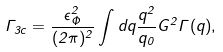<formula> <loc_0><loc_0><loc_500><loc_500>\Gamma _ { 3 c } = \frac { \epsilon _ { \Phi } ^ { 2 } } { ( 2 \pi ) ^ { 2 } } \int d q \frac { q ^ { 2 } } { q _ { 0 } } G ^ { 2 } \Gamma ( q ) ,</formula> 